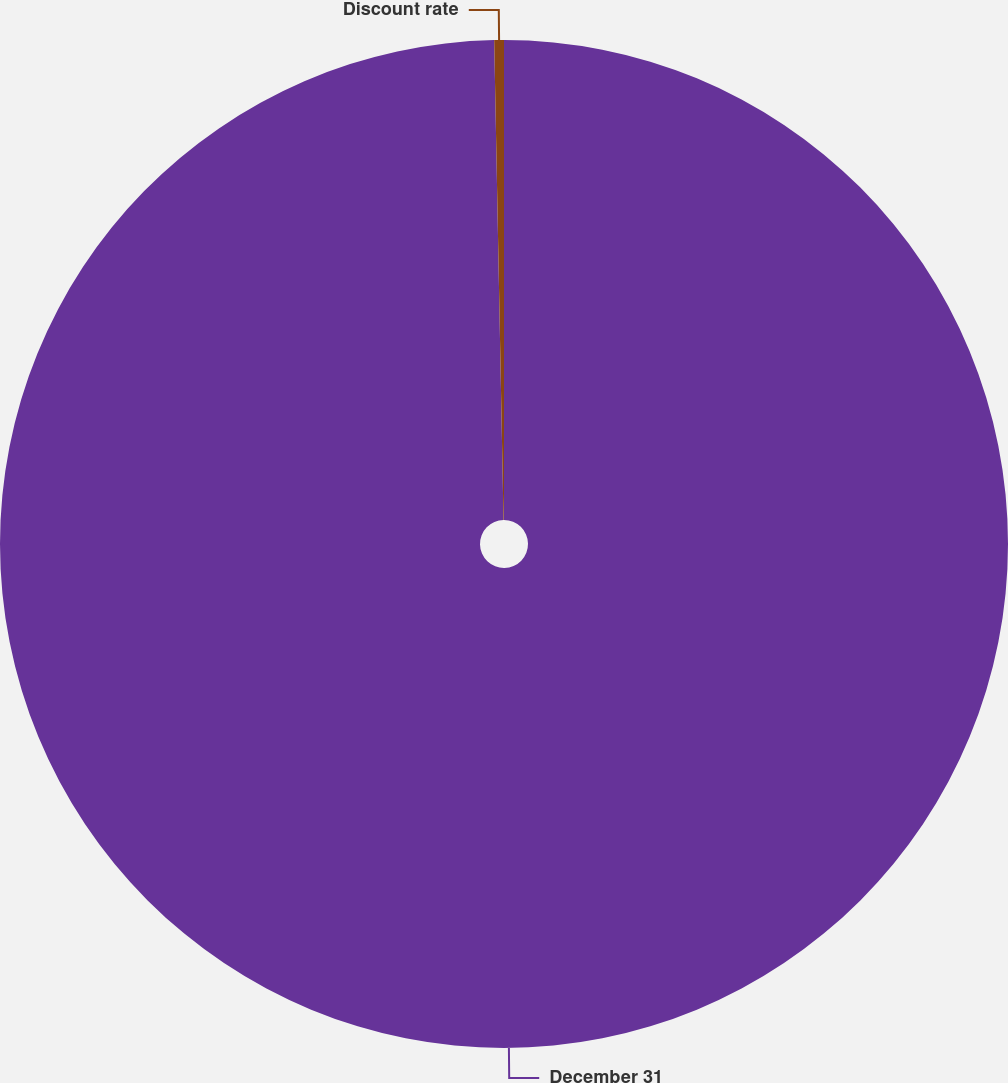Convert chart to OTSL. <chart><loc_0><loc_0><loc_500><loc_500><pie_chart><fcel>December 31<fcel>Discount rate<nl><fcel>99.69%<fcel>0.31%<nl></chart> 